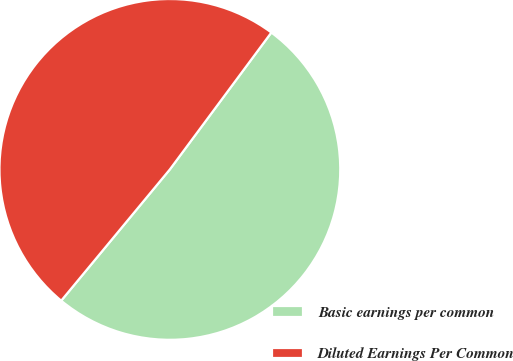<chart> <loc_0><loc_0><loc_500><loc_500><pie_chart><fcel>Basic earnings per common<fcel>Diluted Earnings Per Common<nl><fcel>50.85%<fcel>49.15%<nl></chart> 